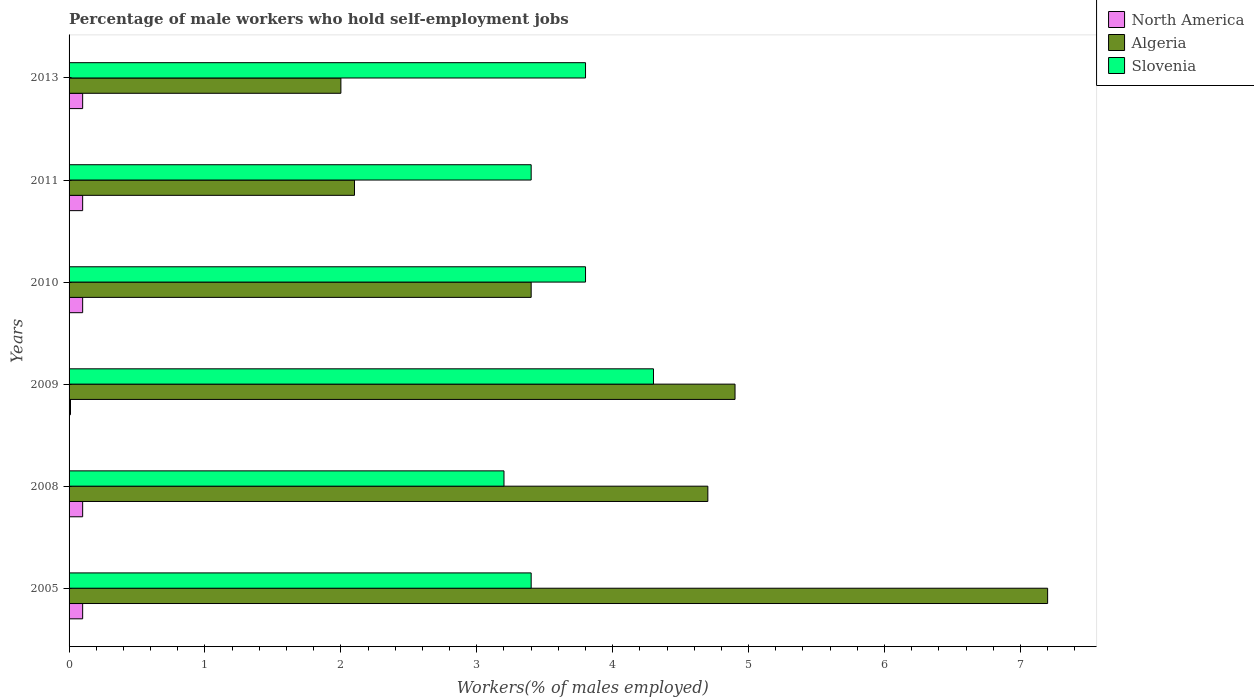How many different coloured bars are there?
Offer a terse response. 3. Are the number of bars per tick equal to the number of legend labels?
Your response must be concise. Yes. Are the number of bars on each tick of the Y-axis equal?
Offer a very short reply. Yes. How many bars are there on the 4th tick from the bottom?
Ensure brevity in your answer.  3. What is the percentage of self-employed male workers in North America in 2011?
Give a very brief answer. 0.1. Across all years, what is the maximum percentage of self-employed male workers in North America?
Keep it short and to the point. 0.1. Across all years, what is the minimum percentage of self-employed male workers in North America?
Your answer should be very brief. 0.01. In which year was the percentage of self-employed male workers in Algeria minimum?
Give a very brief answer. 2013. What is the total percentage of self-employed male workers in Algeria in the graph?
Provide a short and direct response. 24.3. What is the difference between the percentage of self-employed male workers in Algeria in 2005 and that in 2013?
Ensure brevity in your answer.  5.2. What is the difference between the percentage of self-employed male workers in Slovenia in 2005 and the percentage of self-employed male workers in Algeria in 2013?
Your answer should be compact. 1.4. What is the average percentage of self-employed male workers in Algeria per year?
Your answer should be compact. 4.05. In the year 2013, what is the difference between the percentage of self-employed male workers in North America and percentage of self-employed male workers in Algeria?
Give a very brief answer. -1.9. In how many years, is the percentage of self-employed male workers in Algeria greater than 3.6 %?
Offer a very short reply. 3. What is the ratio of the percentage of self-employed male workers in Slovenia in 2005 to that in 2008?
Your answer should be compact. 1.06. Is the percentage of self-employed male workers in Algeria in 2009 less than that in 2013?
Your response must be concise. No. Is the difference between the percentage of self-employed male workers in North America in 2008 and 2013 greater than the difference between the percentage of self-employed male workers in Algeria in 2008 and 2013?
Your answer should be compact. No. What is the difference between the highest and the second highest percentage of self-employed male workers in Slovenia?
Provide a succinct answer. 0.5. What is the difference between the highest and the lowest percentage of self-employed male workers in Slovenia?
Give a very brief answer. 1.1. What does the 2nd bar from the top in 2008 represents?
Provide a succinct answer. Algeria. Is it the case that in every year, the sum of the percentage of self-employed male workers in Slovenia and percentage of self-employed male workers in Algeria is greater than the percentage of self-employed male workers in North America?
Offer a very short reply. Yes. How many years are there in the graph?
Make the answer very short. 6. Does the graph contain any zero values?
Offer a terse response. No. Does the graph contain grids?
Give a very brief answer. No. How many legend labels are there?
Your answer should be compact. 3. What is the title of the graph?
Give a very brief answer. Percentage of male workers who hold self-employment jobs. Does "Congo (Democratic)" appear as one of the legend labels in the graph?
Your answer should be compact. No. What is the label or title of the X-axis?
Your answer should be compact. Workers(% of males employed). What is the Workers(% of males employed) in North America in 2005?
Your response must be concise. 0.1. What is the Workers(% of males employed) in Algeria in 2005?
Your response must be concise. 7.2. What is the Workers(% of males employed) of Slovenia in 2005?
Your answer should be very brief. 3.4. What is the Workers(% of males employed) in North America in 2008?
Your answer should be very brief. 0.1. What is the Workers(% of males employed) of Algeria in 2008?
Give a very brief answer. 4.7. What is the Workers(% of males employed) in Slovenia in 2008?
Keep it short and to the point. 3.2. What is the Workers(% of males employed) in North America in 2009?
Your answer should be compact. 0.01. What is the Workers(% of males employed) in Algeria in 2009?
Your answer should be very brief. 4.9. What is the Workers(% of males employed) in Slovenia in 2009?
Provide a short and direct response. 4.3. What is the Workers(% of males employed) of North America in 2010?
Offer a very short reply. 0.1. What is the Workers(% of males employed) of Algeria in 2010?
Provide a succinct answer. 3.4. What is the Workers(% of males employed) of Slovenia in 2010?
Offer a very short reply. 3.8. What is the Workers(% of males employed) of North America in 2011?
Provide a short and direct response. 0.1. What is the Workers(% of males employed) in Algeria in 2011?
Your answer should be very brief. 2.1. What is the Workers(% of males employed) of Slovenia in 2011?
Give a very brief answer. 3.4. What is the Workers(% of males employed) of North America in 2013?
Your response must be concise. 0.1. What is the Workers(% of males employed) of Algeria in 2013?
Offer a terse response. 2. What is the Workers(% of males employed) of Slovenia in 2013?
Keep it short and to the point. 3.8. Across all years, what is the maximum Workers(% of males employed) in North America?
Your response must be concise. 0.1. Across all years, what is the maximum Workers(% of males employed) in Algeria?
Provide a short and direct response. 7.2. Across all years, what is the maximum Workers(% of males employed) of Slovenia?
Make the answer very short. 4.3. Across all years, what is the minimum Workers(% of males employed) in North America?
Offer a very short reply. 0.01. Across all years, what is the minimum Workers(% of males employed) in Slovenia?
Offer a terse response. 3.2. What is the total Workers(% of males employed) of North America in the graph?
Provide a succinct answer. 0.51. What is the total Workers(% of males employed) of Algeria in the graph?
Keep it short and to the point. 24.3. What is the total Workers(% of males employed) of Slovenia in the graph?
Keep it short and to the point. 21.9. What is the difference between the Workers(% of males employed) of Algeria in 2005 and that in 2008?
Your response must be concise. 2.5. What is the difference between the Workers(% of males employed) in Slovenia in 2005 and that in 2008?
Your response must be concise. 0.2. What is the difference between the Workers(% of males employed) of North America in 2005 and that in 2009?
Your response must be concise. 0.09. What is the difference between the Workers(% of males employed) in Algeria in 2005 and that in 2009?
Make the answer very short. 2.3. What is the difference between the Workers(% of males employed) of Slovenia in 2005 and that in 2009?
Your answer should be very brief. -0.9. What is the difference between the Workers(% of males employed) of Slovenia in 2005 and that in 2011?
Give a very brief answer. 0. What is the difference between the Workers(% of males employed) of Algeria in 2005 and that in 2013?
Your answer should be compact. 5.2. What is the difference between the Workers(% of males employed) in Slovenia in 2005 and that in 2013?
Provide a short and direct response. -0.4. What is the difference between the Workers(% of males employed) in North America in 2008 and that in 2009?
Your answer should be compact. 0.09. What is the difference between the Workers(% of males employed) in Algeria in 2008 and that in 2009?
Your answer should be very brief. -0.2. What is the difference between the Workers(% of males employed) in North America in 2008 and that in 2010?
Your answer should be compact. 0. What is the difference between the Workers(% of males employed) in Algeria in 2008 and that in 2010?
Your response must be concise. 1.3. What is the difference between the Workers(% of males employed) of Algeria in 2008 and that in 2011?
Make the answer very short. 2.6. What is the difference between the Workers(% of males employed) in Slovenia in 2008 and that in 2011?
Keep it short and to the point. -0.2. What is the difference between the Workers(% of males employed) in North America in 2008 and that in 2013?
Offer a terse response. 0. What is the difference between the Workers(% of males employed) of Algeria in 2008 and that in 2013?
Your answer should be very brief. 2.7. What is the difference between the Workers(% of males employed) of Slovenia in 2008 and that in 2013?
Offer a very short reply. -0.6. What is the difference between the Workers(% of males employed) of North America in 2009 and that in 2010?
Provide a succinct answer. -0.09. What is the difference between the Workers(% of males employed) of Algeria in 2009 and that in 2010?
Keep it short and to the point. 1.5. What is the difference between the Workers(% of males employed) of North America in 2009 and that in 2011?
Offer a terse response. -0.09. What is the difference between the Workers(% of males employed) in Algeria in 2009 and that in 2011?
Provide a short and direct response. 2.8. What is the difference between the Workers(% of males employed) in North America in 2009 and that in 2013?
Ensure brevity in your answer.  -0.09. What is the difference between the Workers(% of males employed) in Slovenia in 2009 and that in 2013?
Offer a very short reply. 0.5. What is the difference between the Workers(% of males employed) in Algeria in 2010 and that in 2011?
Your answer should be very brief. 1.3. What is the difference between the Workers(% of males employed) of North America in 2010 and that in 2013?
Your response must be concise. 0. What is the difference between the Workers(% of males employed) of Slovenia in 2010 and that in 2013?
Ensure brevity in your answer.  0. What is the difference between the Workers(% of males employed) in Algeria in 2011 and that in 2013?
Offer a very short reply. 0.1. What is the difference between the Workers(% of males employed) of North America in 2005 and the Workers(% of males employed) of Slovenia in 2008?
Ensure brevity in your answer.  -3.1. What is the difference between the Workers(% of males employed) of Algeria in 2005 and the Workers(% of males employed) of Slovenia in 2008?
Your answer should be compact. 4. What is the difference between the Workers(% of males employed) in North America in 2005 and the Workers(% of males employed) in Algeria in 2010?
Provide a short and direct response. -3.3. What is the difference between the Workers(% of males employed) of Algeria in 2005 and the Workers(% of males employed) of Slovenia in 2010?
Offer a very short reply. 3.4. What is the difference between the Workers(% of males employed) of North America in 2005 and the Workers(% of males employed) of Slovenia in 2013?
Keep it short and to the point. -3.7. What is the difference between the Workers(% of males employed) of North America in 2008 and the Workers(% of males employed) of Slovenia in 2009?
Offer a terse response. -4.2. What is the difference between the Workers(% of males employed) in Algeria in 2008 and the Workers(% of males employed) in Slovenia in 2009?
Give a very brief answer. 0.4. What is the difference between the Workers(% of males employed) of Algeria in 2008 and the Workers(% of males employed) of Slovenia in 2010?
Your answer should be compact. 0.9. What is the difference between the Workers(% of males employed) in North America in 2008 and the Workers(% of males employed) in Algeria in 2013?
Your response must be concise. -1.9. What is the difference between the Workers(% of males employed) of North America in 2008 and the Workers(% of males employed) of Slovenia in 2013?
Your answer should be compact. -3.7. What is the difference between the Workers(% of males employed) of Algeria in 2008 and the Workers(% of males employed) of Slovenia in 2013?
Offer a terse response. 0.9. What is the difference between the Workers(% of males employed) in North America in 2009 and the Workers(% of males employed) in Algeria in 2010?
Ensure brevity in your answer.  -3.39. What is the difference between the Workers(% of males employed) in North America in 2009 and the Workers(% of males employed) in Slovenia in 2010?
Give a very brief answer. -3.79. What is the difference between the Workers(% of males employed) in North America in 2009 and the Workers(% of males employed) in Algeria in 2011?
Ensure brevity in your answer.  -2.09. What is the difference between the Workers(% of males employed) in North America in 2009 and the Workers(% of males employed) in Slovenia in 2011?
Your answer should be very brief. -3.39. What is the difference between the Workers(% of males employed) of North America in 2009 and the Workers(% of males employed) of Algeria in 2013?
Provide a short and direct response. -1.99. What is the difference between the Workers(% of males employed) in North America in 2009 and the Workers(% of males employed) in Slovenia in 2013?
Provide a succinct answer. -3.79. What is the difference between the Workers(% of males employed) in Algeria in 2009 and the Workers(% of males employed) in Slovenia in 2013?
Offer a very short reply. 1.1. What is the difference between the Workers(% of males employed) of Algeria in 2010 and the Workers(% of males employed) of Slovenia in 2011?
Your response must be concise. 0. What is the difference between the Workers(% of males employed) of North America in 2010 and the Workers(% of males employed) of Algeria in 2013?
Your answer should be very brief. -1.9. What is the difference between the Workers(% of males employed) in North America in 2010 and the Workers(% of males employed) in Slovenia in 2013?
Offer a terse response. -3.7. What is the difference between the Workers(% of males employed) of Algeria in 2010 and the Workers(% of males employed) of Slovenia in 2013?
Provide a short and direct response. -0.4. What is the difference between the Workers(% of males employed) in Algeria in 2011 and the Workers(% of males employed) in Slovenia in 2013?
Keep it short and to the point. -1.7. What is the average Workers(% of males employed) of North America per year?
Provide a short and direct response. 0.09. What is the average Workers(% of males employed) of Algeria per year?
Your answer should be very brief. 4.05. What is the average Workers(% of males employed) in Slovenia per year?
Make the answer very short. 3.65. In the year 2008, what is the difference between the Workers(% of males employed) of North America and Workers(% of males employed) of Algeria?
Ensure brevity in your answer.  -4.6. In the year 2009, what is the difference between the Workers(% of males employed) in North America and Workers(% of males employed) in Algeria?
Ensure brevity in your answer.  -4.89. In the year 2009, what is the difference between the Workers(% of males employed) of North America and Workers(% of males employed) of Slovenia?
Keep it short and to the point. -4.29. In the year 2009, what is the difference between the Workers(% of males employed) of Algeria and Workers(% of males employed) of Slovenia?
Your answer should be compact. 0.6. In the year 2010, what is the difference between the Workers(% of males employed) of North America and Workers(% of males employed) of Slovenia?
Provide a short and direct response. -3.7. In the year 2011, what is the difference between the Workers(% of males employed) of North America and Workers(% of males employed) of Algeria?
Offer a very short reply. -2. In the year 2011, what is the difference between the Workers(% of males employed) of Algeria and Workers(% of males employed) of Slovenia?
Your answer should be compact. -1.3. In the year 2013, what is the difference between the Workers(% of males employed) of North America and Workers(% of males employed) of Algeria?
Your answer should be compact. -1.9. In the year 2013, what is the difference between the Workers(% of males employed) in Algeria and Workers(% of males employed) in Slovenia?
Provide a short and direct response. -1.8. What is the ratio of the Workers(% of males employed) in North America in 2005 to that in 2008?
Provide a succinct answer. 1. What is the ratio of the Workers(% of males employed) of Algeria in 2005 to that in 2008?
Ensure brevity in your answer.  1.53. What is the ratio of the Workers(% of males employed) in North America in 2005 to that in 2009?
Provide a succinct answer. 9.5. What is the ratio of the Workers(% of males employed) of Algeria in 2005 to that in 2009?
Offer a terse response. 1.47. What is the ratio of the Workers(% of males employed) of Slovenia in 2005 to that in 2009?
Offer a terse response. 0.79. What is the ratio of the Workers(% of males employed) in Algeria in 2005 to that in 2010?
Offer a very short reply. 2.12. What is the ratio of the Workers(% of males employed) in Slovenia in 2005 to that in 2010?
Ensure brevity in your answer.  0.89. What is the ratio of the Workers(% of males employed) of North America in 2005 to that in 2011?
Your response must be concise. 1. What is the ratio of the Workers(% of males employed) in Algeria in 2005 to that in 2011?
Provide a succinct answer. 3.43. What is the ratio of the Workers(% of males employed) of Slovenia in 2005 to that in 2011?
Keep it short and to the point. 1. What is the ratio of the Workers(% of males employed) of Slovenia in 2005 to that in 2013?
Keep it short and to the point. 0.89. What is the ratio of the Workers(% of males employed) of North America in 2008 to that in 2009?
Your answer should be very brief. 9.5. What is the ratio of the Workers(% of males employed) in Algeria in 2008 to that in 2009?
Make the answer very short. 0.96. What is the ratio of the Workers(% of males employed) in Slovenia in 2008 to that in 2009?
Your answer should be very brief. 0.74. What is the ratio of the Workers(% of males employed) of Algeria in 2008 to that in 2010?
Offer a terse response. 1.38. What is the ratio of the Workers(% of males employed) of Slovenia in 2008 to that in 2010?
Offer a terse response. 0.84. What is the ratio of the Workers(% of males employed) in North America in 2008 to that in 2011?
Ensure brevity in your answer.  1. What is the ratio of the Workers(% of males employed) in Algeria in 2008 to that in 2011?
Give a very brief answer. 2.24. What is the ratio of the Workers(% of males employed) in Slovenia in 2008 to that in 2011?
Offer a terse response. 0.94. What is the ratio of the Workers(% of males employed) of North America in 2008 to that in 2013?
Ensure brevity in your answer.  1. What is the ratio of the Workers(% of males employed) in Algeria in 2008 to that in 2013?
Give a very brief answer. 2.35. What is the ratio of the Workers(% of males employed) of Slovenia in 2008 to that in 2013?
Ensure brevity in your answer.  0.84. What is the ratio of the Workers(% of males employed) in North America in 2009 to that in 2010?
Your answer should be very brief. 0.11. What is the ratio of the Workers(% of males employed) of Algeria in 2009 to that in 2010?
Give a very brief answer. 1.44. What is the ratio of the Workers(% of males employed) of Slovenia in 2009 to that in 2010?
Keep it short and to the point. 1.13. What is the ratio of the Workers(% of males employed) of North America in 2009 to that in 2011?
Your answer should be compact. 0.11. What is the ratio of the Workers(% of males employed) of Algeria in 2009 to that in 2011?
Offer a terse response. 2.33. What is the ratio of the Workers(% of males employed) of Slovenia in 2009 to that in 2011?
Your answer should be compact. 1.26. What is the ratio of the Workers(% of males employed) of North America in 2009 to that in 2013?
Offer a terse response. 0.11. What is the ratio of the Workers(% of males employed) in Algeria in 2009 to that in 2013?
Offer a very short reply. 2.45. What is the ratio of the Workers(% of males employed) of Slovenia in 2009 to that in 2013?
Your answer should be compact. 1.13. What is the ratio of the Workers(% of males employed) in Algeria in 2010 to that in 2011?
Your answer should be compact. 1.62. What is the ratio of the Workers(% of males employed) of Slovenia in 2010 to that in 2011?
Your answer should be compact. 1.12. What is the ratio of the Workers(% of males employed) of Algeria in 2010 to that in 2013?
Your answer should be very brief. 1.7. What is the ratio of the Workers(% of males employed) in Slovenia in 2010 to that in 2013?
Your response must be concise. 1. What is the ratio of the Workers(% of males employed) of Slovenia in 2011 to that in 2013?
Your response must be concise. 0.89. What is the difference between the highest and the second highest Workers(% of males employed) of North America?
Provide a succinct answer. 0. What is the difference between the highest and the second highest Workers(% of males employed) of Algeria?
Offer a very short reply. 2.3. What is the difference between the highest and the second highest Workers(% of males employed) in Slovenia?
Make the answer very short. 0.5. What is the difference between the highest and the lowest Workers(% of males employed) of North America?
Make the answer very short. 0.09. What is the difference between the highest and the lowest Workers(% of males employed) of Algeria?
Make the answer very short. 5.2. 